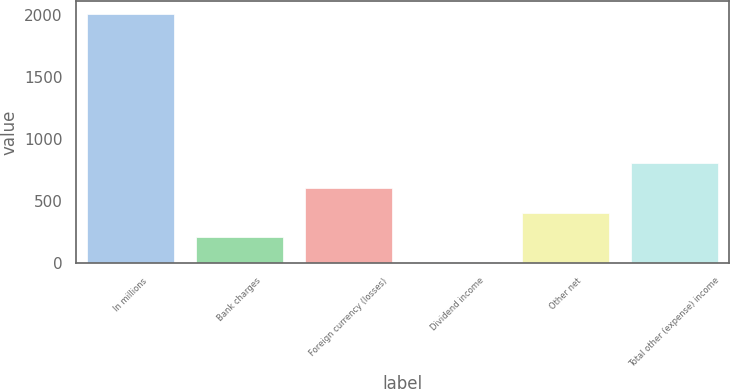<chart> <loc_0><loc_0><loc_500><loc_500><bar_chart><fcel>In millions<fcel>Bank charges<fcel>Foreign currency (losses)<fcel>Dividend income<fcel>Other net<fcel>Total other (expense) income<nl><fcel>2008<fcel>206.2<fcel>606.6<fcel>6<fcel>406.4<fcel>806.8<nl></chart> 